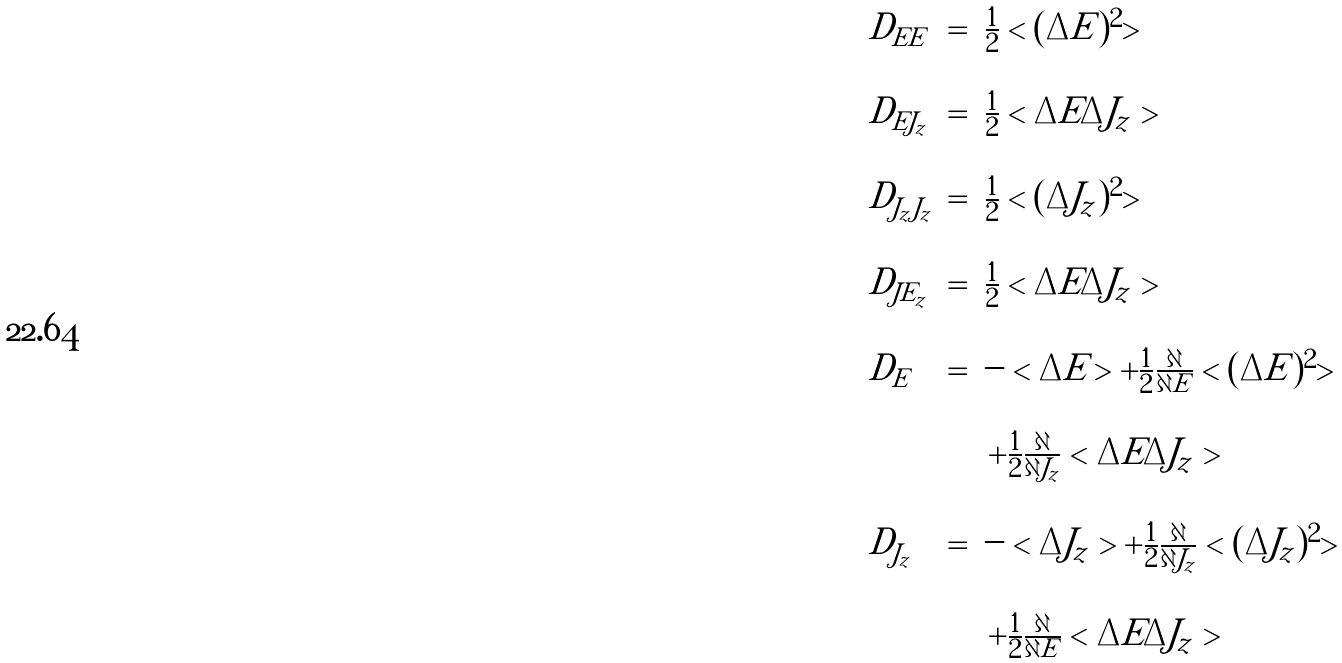Convert formula to latex. <formula><loc_0><loc_0><loc_500><loc_500>\begin{array} { l c l } D _ { E E } & = & \frac { 1 } { 2 } < ( \Delta E ) ^ { 2 } > \\ & & \\ D _ { E J _ { z } } & = & \frac { 1 } { 2 } < \Delta E \Delta J _ { z } > \\ & & \\ D _ { J _ { z } J _ { z } } & = & \frac { 1 } { 2 } < ( \Delta J _ { z } ) ^ { 2 } > \\ & & \\ D _ { J E _ { z } } & = & \frac { 1 } { 2 } < \Delta E \Delta J _ { z } > \\ & & \\ D _ { E } & = & - < \Delta E > + \frac { 1 } { 2 } \frac { \partial } { \partial E } < ( \Delta E ) ^ { 2 } > \\ & & \\ & & \, + \frac { 1 } { 2 } \frac { \partial } { \partial J _ { z } } < \Delta E \Delta J _ { z } > \\ & & \\ D _ { J _ { z } } & = & - < \Delta J _ { z } > + \frac { 1 } { 2 } \frac { \partial } { \partial J _ { z } } < ( \Delta J _ { z } ) ^ { 2 } > \\ & & \\ & & \, + \frac { 1 } { 2 } \frac { \partial } { \partial E } < \Delta E \Delta J _ { z } > \end{array}</formula> 